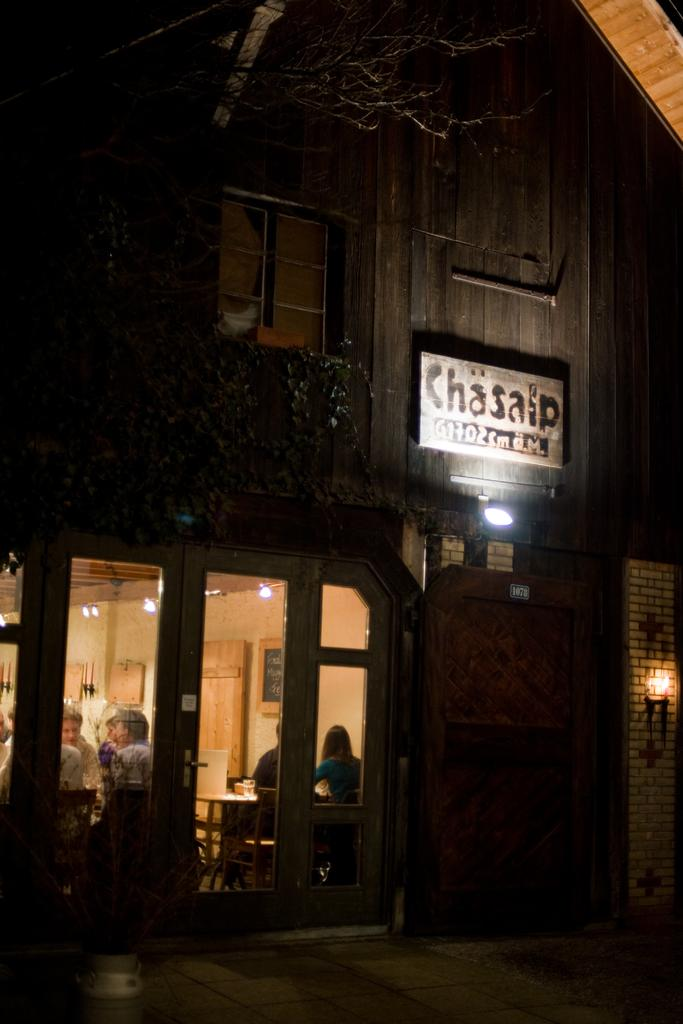<image>
Create a compact narrative representing the image presented. Restaurant with a white sign outdoors that says Chasalp. 